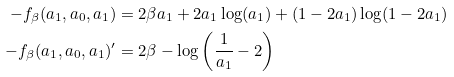Convert formula to latex. <formula><loc_0><loc_0><loc_500><loc_500>- f _ { \beta } ( a _ { 1 } , a _ { 0 } , a _ { 1 } ) & = 2 \beta a _ { 1 } + 2 a _ { 1 } \log ( a _ { 1 } ) + ( 1 - 2 a _ { 1 } ) \log ( 1 - 2 a _ { 1 } ) \\ - f _ { \beta } ( a _ { 1 } , a _ { 0 } , a _ { 1 } ) ^ { \prime } & = 2 \beta - \log \left ( \frac { 1 } { a _ { 1 } } - 2 \right )</formula> 